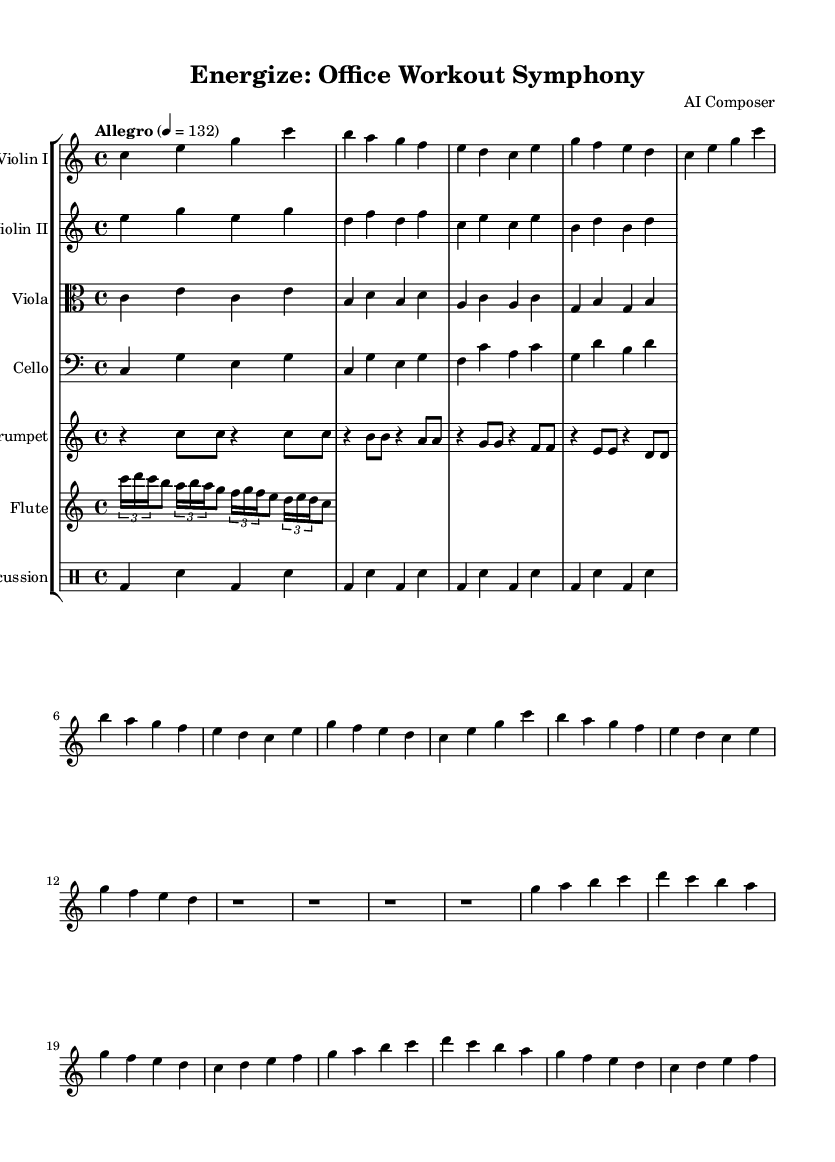What is the key signature of this music? The key signature is C major, which is indicated by the lack of sharps or flats at the beginning of the staff.
Answer: C major What is the time signature of this piece? The time signature shown on the first line of the score is 4/4, meaning there are four beats per measure and the quarter note receives one beat.
Answer: 4/4 What is the tempo marking of this symphony? The tempo marking is "Allegro" with a metronome marking of 132, which indicates a fast and lively pace.
Answer: Allegro 4 = 132 How many total measures are present in the main themes? The main themes consist of two sections, each with 8 measures, leading to a total of 16 measures for both themes.
Answer: 16 What instruments are part of this symphony? The symphony includes violin I, violin II, viola, cello, trumpet, flute, and percussion, as indicated by the staff labels.
Answer: Violin I, Violin II, Viola, Cello, Trumpet, Flute, Percussion What notable musical element is included as a bridge in the symphony? The electronic bridge is a section where all the parts rest, indicated by resting measures without notes, reflecting a break before the next theme.
Answer: Electronic bridge How does the rest section contribute to the overall structure of the piece? The rest section serves as a transition that creates contrast, allowing for reflection on the preceding themes before moving forward, enhancing the symphonic structure.
Answer: Transition 